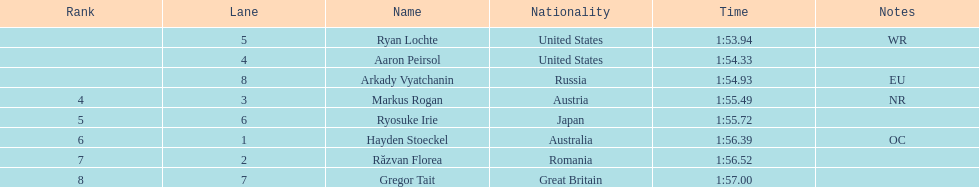Between russia and japan, which has the more extended time? Japan. Parse the table in full. {'header': ['Rank', 'Lane', 'Name', 'Nationality', 'Time', 'Notes'], 'rows': [['', '5', 'Ryan Lochte', 'United States', '1:53.94', 'WR'], ['', '4', 'Aaron Peirsol', 'United States', '1:54.33', ''], ['', '8', 'Arkady Vyatchanin', 'Russia', '1:54.93', 'EU'], ['4', '3', 'Markus Rogan', 'Austria', '1:55.49', 'NR'], ['5', '6', 'Ryosuke Irie', 'Japan', '1:55.72', ''], ['6', '1', 'Hayden Stoeckel', 'Australia', '1:56.39', 'OC'], ['7', '2', 'Răzvan Florea', 'Romania', '1:56.52', ''], ['8', '7', 'Gregor Tait', 'Great Britain', '1:57.00', '']]} 